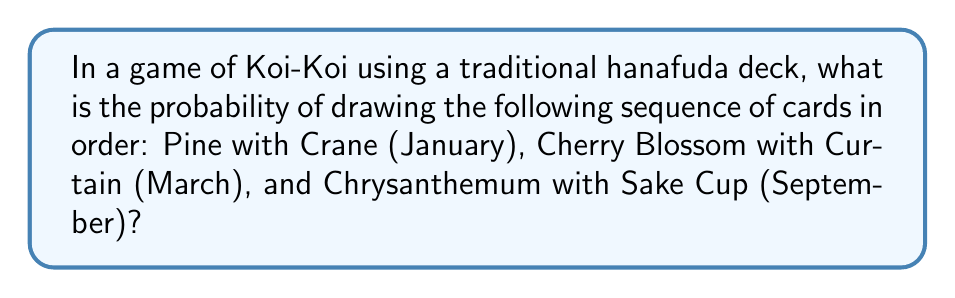Give your solution to this math problem. Let's approach this step-by-step:

1) A hanafuda deck consists of 48 cards, with 4 cards for each of the 12 months.

2) For each month, there is only one special card (like the Crane, Curtain, or Sake Cup).

3) We need to calculate the probability of drawing these three specific cards in this exact order.

4) For the first draw (Pine with Crane):
   Probability = $\frac{1}{48}$

5) After drawing the first card, there are 47 cards left in the deck.
   For the second draw (Cherry Blossom with Curtain):
   Probability = $\frac{1}{47}$

6) After the second draw, there are 46 cards left.
   For the third draw (Chrysanthemum with Sake Cup):
   Probability = $\frac{1}{46}$

7) The probability of all these events occurring in this specific order is the product of their individual probabilities:

   $$P(\text{sequence}) = \frac{1}{48} \times \frac{1}{47} \times \frac{1}{46}$$

8) Simplifying:
   $$P(\text{sequence}) = \frac{1}{103,776}$$
Answer: $\frac{1}{103,776}$ 